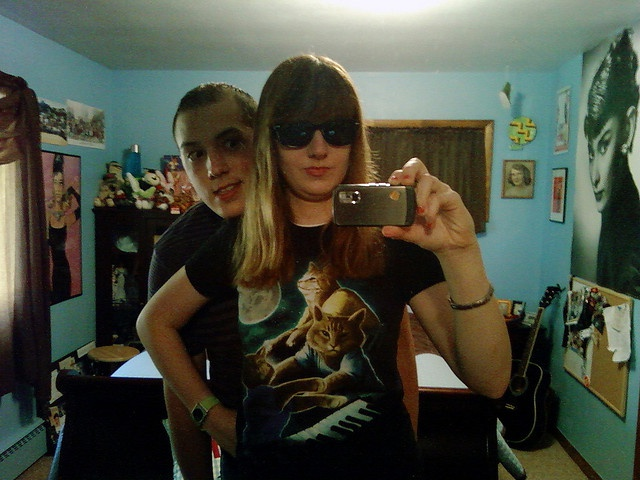Describe the objects in this image and their specific colors. I can see people in gray, black, olive, and maroon tones, people in gray, black, maroon, and olive tones, chair in gray, black, lightblue, and darkgreen tones, people in gray, black, darkgreen, teal, and darkgray tones, and bed in gray, black, and lightblue tones in this image. 